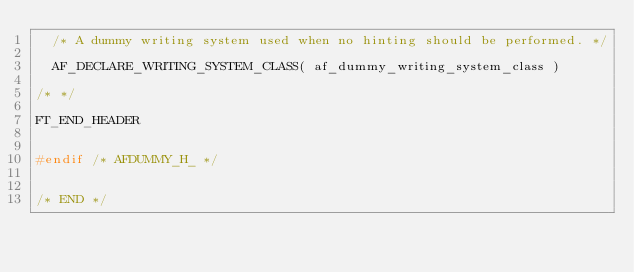<code> <loc_0><loc_0><loc_500><loc_500><_C_>  /* A dummy writing system used when no hinting should be performed. */

  AF_DECLARE_WRITING_SYSTEM_CLASS( af_dummy_writing_system_class )

/* */

FT_END_HEADER


#endif /* AFDUMMY_H_ */


/* END */
</code> 